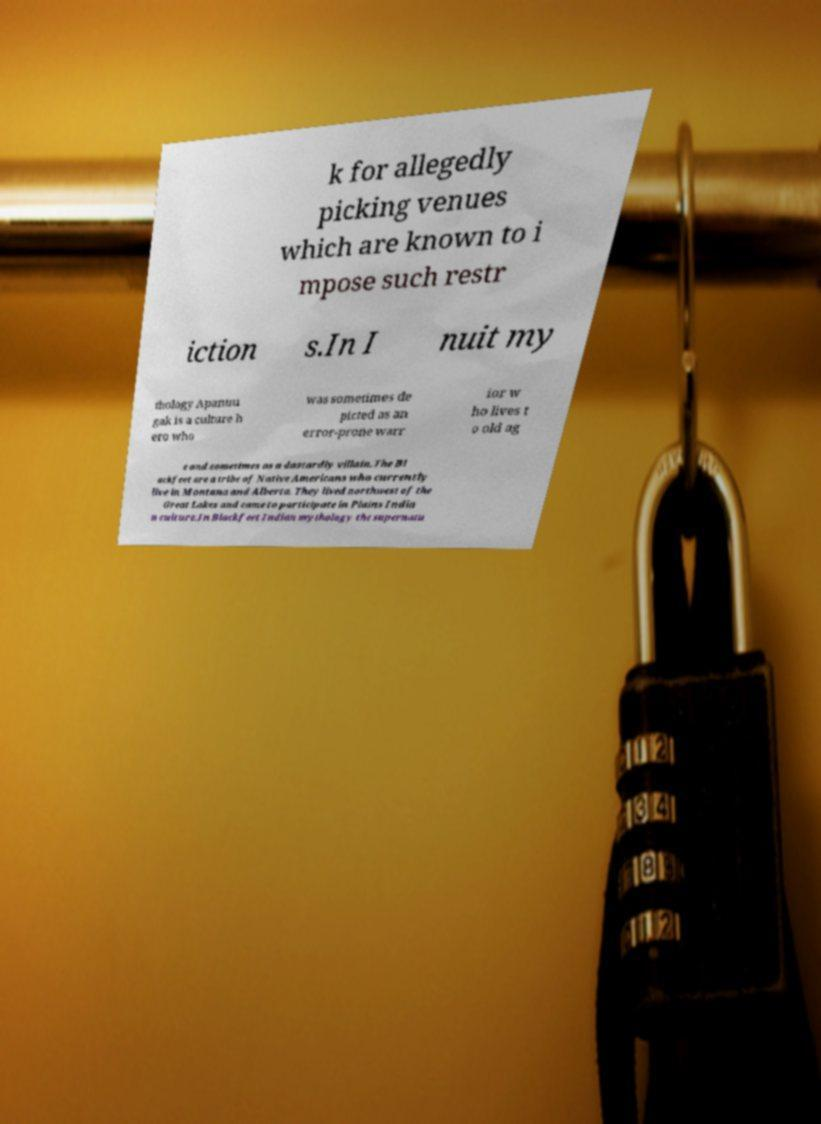Could you extract and type out the text from this image? k for allegedly picking venues which are known to i mpose such restr iction s.In I nuit my thology Apanuu gak is a culture h ero who was sometimes de picted as an error-prone warr ior w ho lives t o old ag e and sometimes as a dastardly villain.The Bl ackfeet are a tribe of Native Americans who currently live in Montana and Alberta. They lived northwest of the Great Lakes and came to participate in Plains India n culture.In Blackfeet Indian mythology the supernatu 